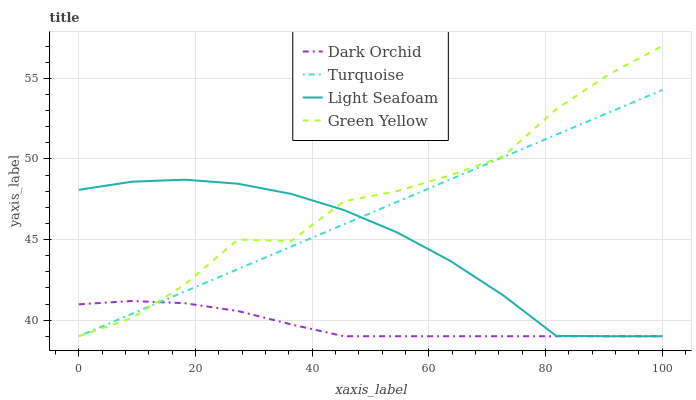Does Dark Orchid have the minimum area under the curve?
Answer yes or no. Yes. Does Green Yellow have the maximum area under the curve?
Answer yes or no. Yes. Does Light Seafoam have the minimum area under the curve?
Answer yes or no. No. Does Light Seafoam have the maximum area under the curve?
Answer yes or no. No. Is Turquoise the smoothest?
Answer yes or no. Yes. Is Green Yellow the roughest?
Answer yes or no. Yes. Is Light Seafoam the smoothest?
Answer yes or no. No. Is Light Seafoam the roughest?
Answer yes or no. No. Does Turquoise have the lowest value?
Answer yes or no. Yes. Does Green Yellow have the highest value?
Answer yes or no. Yes. Does Light Seafoam have the highest value?
Answer yes or no. No. Does Dark Orchid intersect Green Yellow?
Answer yes or no. Yes. Is Dark Orchid less than Green Yellow?
Answer yes or no. No. Is Dark Orchid greater than Green Yellow?
Answer yes or no. No. 